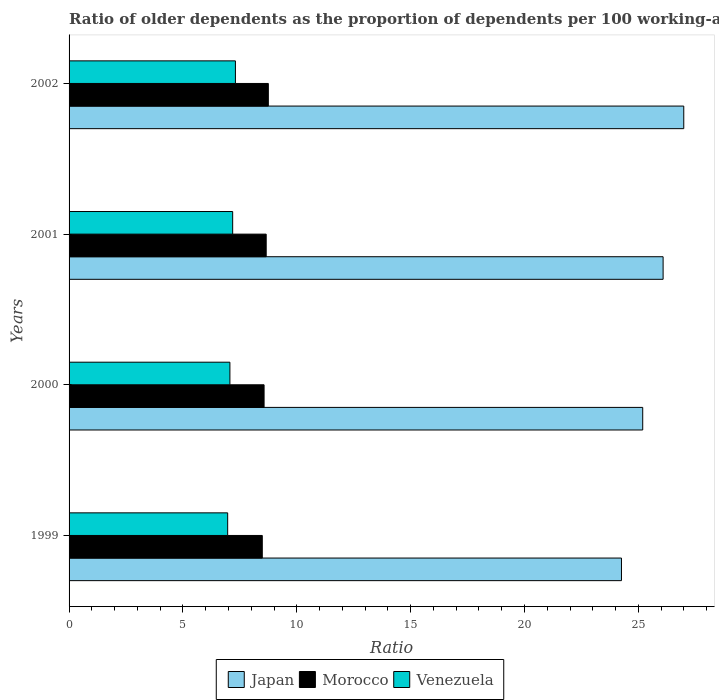How many different coloured bars are there?
Your answer should be compact. 3. How many groups of bars are there?
Offer a very short reply. 4. Are the number of bars per tick equal to the number of legend labels?
Provide a succinct answer. Yes. What is the age dependency ratio(old) in Morocco in 1999?
Make the answer very short. 8.48. Across all years, what is the maximum age dependency ratio(old) in Venezuela?
Your response must be concise. 7.31. Across all years, what is the minimum age dependency ratio(old) in Venezuela?
Your answer should be very brief. 6.96. What is the total age dependency ratio(old) in Morocco in the graph?
Provide a short and direct response. 34.46. What is the difference between the age dependency ratio(old) in Morocco in 2000 and that in 2002?
Offer a very short reply. -0.19. What is the difference between the age dependency ratio(old) in Venezuela in 2000 and the age dependency ratio(old) in Morocco in 2001?
Offer a terse response. -1.59. What is the average age dependency ratio(old) in Morocco per year?
Make the answer very short. 8.61. In the year 2001, what is the difference between the age dependency ratio(old) in Japan and age dependency ratio(old) in Venezuela?
Make the answer very short. 18.9. In how many years, is the age dependency ratio(old) in Morocco greater than 4 ?
Provide a short and direct response. 4. What is the ratio of the age dependency ratio(old) in Morocco in 1999 to that in 2002?
Your response must be concise. 0.97. Is the age dependency ratio(old) in Morocco in 1999 less than that in 2001?
Make the answer very short. Yes. Is the difference between the age dependency ratio(old) in Japan in 2001 and 2002 greater than the difference between the age dependency ratio(old) in Venezuela in 2001 and 2002?
Ensure brevity in your answer.  No. What is the difference between the highest and the second highest age dependency ratio(old) in Morocco?
Offer a terse response. 0.09. What is the difference between the highest and the lowest age dependency ratio(old) in Venezuela?
Provide a short and direct response. 0.34. Is the sum of the age dependency ratio(old) in Venezuela in 1999 and 2001 greater than the maximum age dependency ratio(old) in Japan across all years?
Provide a short and direct response. No. What does the 1st bar from the top in 2000 represents?
Provide a short and direct response. Venezuela. What does the 3rd bar from the bottom in 1999 represents?
Offer a terse response. Venezuela. Is it the case that in every year, the sum of the age dependency ratio(old) in Japan and age dependency ratio(old) in Morocco is greater than the age dependency ratio(old) in Venezuela?
Provide a succinct answer. Yes. Are all the bars in the graph horizontal?
Your answer should be very brief. Yes. What is the difference between two consecutive major ticks on the X-axis?
Keep it short and to the point. 5. Does the graph contain grids?
Offer a very short reply. No. Where does the legend appear in the graph?
Make the answer very short. Bottom center. What is the title of the graph?
Your answer should be compact. Ratio of older dependents as the proportion of dependents per 100 working-age population. What is the label or title of the X-axis?
Ensure brevity in your answer.  Ratio. What is the Ratio of Japan in 1999?
Give a very brief answer. 24.26. What is the Ratio of Morocco in 1999?
Provide a short and direct response. 8.48. What is the Ratio in Venezuela in 1999?
Offer a terse response. 6.96. What is the Ratio in Japan in 2000?
Give a very brief answer. 25.19. What is the Ratio in Morocco in 2000?
Offer a very short reply. 8.56. What is the Ratio of Venezuela in 2000?
Provide a short and direct response. 7.06. What is the Ratio of Japan in 2001?
Your answer should be compact. 26.09. What is the Ratio of Morocco in 2001?
Keep it short and to the point. 8.66. What is the Ratio of Venezuela in 2001?
Your answer should be compact. 7.18. What is the Ratio in Japan in 2002?
Provide a short and direct response. 26.99. What is the Ratio in Morocco in 2002?
Ensure brevity in your answer.  8.75. What is the Ratio in Venezuela in 2002?
Provide a succinct answer. 7.31. Across all years, what is the maximum Ratio in Japan?
Ensure brevity in your answer.  26.99. Across all years, what is the maximum Ratio of Morocco?
Provide a succinct answer. 8.75. Across all years, what is the maximum Ratio in Venezuela?
Offer a terse response. 7.31. Across all years, what is the minimum Ratio of Japan?
Your response must be concise. 24.26. Across all years, what is the minimum Ratio in Morocco?
Offer a terse response. 8.48. Across all years, what is the minimum Ratio in Venezuela?
Your response must be concise. 6.96. What is the total Ratio of Japan in the graph?
Give a very brief answer. 102.54. What is the total Ratio in Morocco in the graph?
Keep it short and to the point. 34.46. What is the total Ratio in Venezuela in the graph?
Your answer should be very brief. 28.52. What is the difference between the Ratio in Japan in 1999 and that in 2000?
Provide a succinct answer. -0.93. What is the difference between the Ratio in Morocco in 1999 and that in 2000?
Your response must be concise. -0.08. What is the difference between the Ratio of Venezuela in 1999 and that in 2000?
Offer a terse response. -0.1. What is the difference between the Ratio in Japan in 1999 and that in 2001?
Offer a terse response. -1.83. What is the difference between the Ratio of Morocco in 1999 and that in 2001?
Make the answer very short. -0.17. What is the difference between the Ratio in Venezuela in 1999 and that in 2001?
Offer a very short reply. -0.22. What is the difference between the Ratio of Japan in 1999 and that in 2002?
Offer a terse response. -2.74. What is the difference between the Ratio in Morocco in 1999 and that in 2002?
Make the answer very short. -0.27. What is the difference between the Ratio of Venezuela in 1999 and that in 2002?
Make the answer very short. -0.34. What is the difference between the Ratio of Japan in 2000 and that in 2001?
Ensure brevity in your answer.  -0.9. What is the difference between the Ratio in Morocco in 2000 and that in 2001?
Your answer should be very brief. -0.09. What is the difference between the Ratio in Venezuela in 2000 and that in 2001?
Provide a short and direct response. -0.12. What is the difference between the Ratio in Japan in 2000 and that in 2002?
Keep it short and to the point. -1.8. What is the difference between the Ratio of Morocco in 2000 and that in 2002?
Ensure brevity in your answer.  -0.19. What is the difference between the Ratio in Venezuela in 2000 and that in 2002?
Your answer should be very brief. -0.24. What is the difference between the Ratio of Japan in 2001 and that in 2002?
Offer a terse response. -0.91. What is the difference between the Ratio of Morocco in 2001 and that in 2002?
Offer a very short reply. -0.09. What is the difference between the Ratio in Venezuela in 2001 and that in 2002?
Give a very brief answer. -0.12. What is the difference between the Ratio in Japan in 1999 and the Ratio in Morocco in 2000?
Give a very brief answer. 15.69. What is the difference between the Ratio of Japan in 1999 and the Ratio of Venezuela in 2000?
Ensure brevity in your answer.  17.2. What is the difference between the Ratio of Morocco in 1999 and the Ratio of Venezuela in 2000?
Your answer should be very brief. 1.42. What is the difference between the Ratio of Japan in 1999 and the Ratio of Morocco in 2001?
Give a very brief answer. 15.6. What is the difference between the Ratio of Japan in 1999 and the Ratio of Venezuela in 2001?
Provide a short and direct response. 17.07. What is the difference between the Ratio of Morocco in 1999 and the Ratio of Venezuela in 2001?
Keep it short and to the point. 1.3. What is the difference between the Ratio of Japan in 1999 and the Ratio of Morocco in 2002?
Your response must be concise. 15.51. What is the difference between the Ratio of Japan in 1999 and the Ratio of Venezuela in 2002?
Offer a terse response. 16.95. What is the difference between the Ratio in Morocco in 1999 and the Ratio in Venezuela in 2002?
Make the answer very short. 1.18. What is the difference between the Ratio of Japan in 2000 and the Ratio of Morocco in 2001?
Provide a short and direct response. 16.54. What is the difference between the Ratio in Japan in 2000 and the Ratio in Venezuela in 2001?
Keep it short and to the point. 18.01. What is the difference between the Ratio in Morocco in 2000 and the Ratio in Venezuela in 2001?
Provide a succinct answer. 1.38. What is the difference between the Ratio in Japan in 2000 and the Ratio in Morocco in 2002?
Make the answer very short. 16.44. What is the difference between the Ratio of Japan in 2000 and the Ratio of Venezuela in 2002?
Your answer should be compact. 17.89. What is the difference between the Ratio of Morocco in 2000 and the Ratio of Venezuela in 2002?
Your response must be concise. 1.26. What is the difference between the Ratio in Japan in 2001 and the Ratio in Morocco in 2002?
Make the answer very short. 17.34. What is the difference between the Ratio in Japan in 2001 and the Ratio in Venezuela in 2002?
Offer a very short reply. 18.78. What is the difference between the Ratio in Morocco in 2001 and the Ratio in Venezuela in 2002?
Provide a short and direct response. 1.35. What is the average Ratio of Japan per year?
Keep it short and to the point. 25.63. What is the average Ratio of Morocco per year?
Provide a short and direct response. 8.61. What is the average Ratio of Venezuela per year?
Make the answer very short. 7.13. In the year 1999, what is the difference between the Ratio of Japan and Ratio of Morocco?
Offer a terse response. 15.77. In the year 1999, what is the difference between the Ratio of Japan and Ratio of Venezuela?
Keep it short and to the point. 17.29. In the year 1999, what is the difference between the Ratio in Morocco and Ratio in Venezuela?
Offer a very short reply. 1.52. In the year 2000, what is the difference between the Ratio of Japan and Ratio of Morocco?
Give a very brief answer. 16.63. In the year 2000, what is the difference between the Ratio of Japan and Ratio of Venezuela?
Your answer should be compact. 18.13. In the year 2000, what is the difference between the Ratio in Morocco and Ratio in Venezuela?
Provide a short and direct response. 1.5. In the year 2001, what is the difference between the Ratio in Japan and Ratio in Morocco?
Your response must be concise. 17.43. In the year 2001, what is the difference between the Ratio of Japan and Ratio of Venezuela?
Offer a very short reply. 18.9. In the year 2001, what is the difference between the Ratio in Morocco and Ratio in Venezuela?
Keep it short and to the point. 1.47. In the year 2002, what is the difference between the Ratio in Japan and Ratio in Morocco?
Give a very brief answer. 18.24. In the year 2002, what is the difference between the Ratio in Japan and Ratio in Venezuela?
Offer a very short reply. 19.69. In the year 2002, what is the difference between the Ratio of Morocco and Ratio of Venezuela?
Your answer should be compact. 1.45. What is the ratio of the Ratio of Japan in 1999 to that in 2000?
Ensure brevity in your answer.  0.96. What is the ratio of the Ratio in Japan in 1999 to that in 2001?
Your response must be concise. 0.93. What is the ratio of the Ratio of Morocco in 1999 to that in 2001?
Your answer should be very brief. 0.98. What is the ratio of the Ratio of Venezuela in 1999 to that in 2001?
Your answer should be very brief. 0.97. What is the ratio of the Ratio in Japan in 1999 to that in 2002?
Give a very brief answer. 0.9. What is the ratio of the Ratio in Morocco in 1999 to that in 2002?
Your answer should be very brief. 0.97. What is the ratio of the Ratio of Venezuela in 1999 to that in 2002?
Make the answer very short. 0.95. What is the ratio of the Ratio of Japan in 2000 to that in 2001?
Your answer should be compact. 0.97. What is the ratio of the Ratio of Morocco in 2000 to that in 2001?
Offer a terse response. 0.99. What is the ratio of the Ratio in Venezuela in 2000 to that in 2001?
Provide a succinct answer. 0.98. What is the ratio of the Ratio of Japan in 2000 to that in 2002?
Your answer should be very brief. 0.93. What is the ratio of the Ratio in Morocco in 2000 to that in 2002?
Make the answer very short. 0.98. What is the ratio of the Ratio in Venezuela in 2000 to that in 2002?
Your answer should be very brief. 0.97. What is the ratio of the Ratio of Japan in 2001 to that in 2002?
Keep it short and to the point. 0.97. What is the ratio of the Ratio of Morocco in 2001 to that in 2002?
Provide a short and direct response. 0.99. What is the ratio of the Ratio of Venezuela in 2001 to that in 2002?
Your response must be concise. 0.98. What is the difference between the highest and the second highest Ratio of Japan?
Your response must be concise. 0.91. What is the difference between the highest and the second highest Ratio of Morocco?
Provide a succinct answer. 0.09. What is the difference between the highest and the second highest Ratio of Venezuela?
Your response must be concise. 0.12. What is the difference between the highest and the lowest Ratio of Japan?
Provide a short and direct response. 2.74. What is the difference between the highest and the lowest Ratio in Morocco?
Keep it short and to the point. 0.27. What is the difference between the highest and the lowest Ratio in Venezuela?
Give a very brief answer. 0.34. 